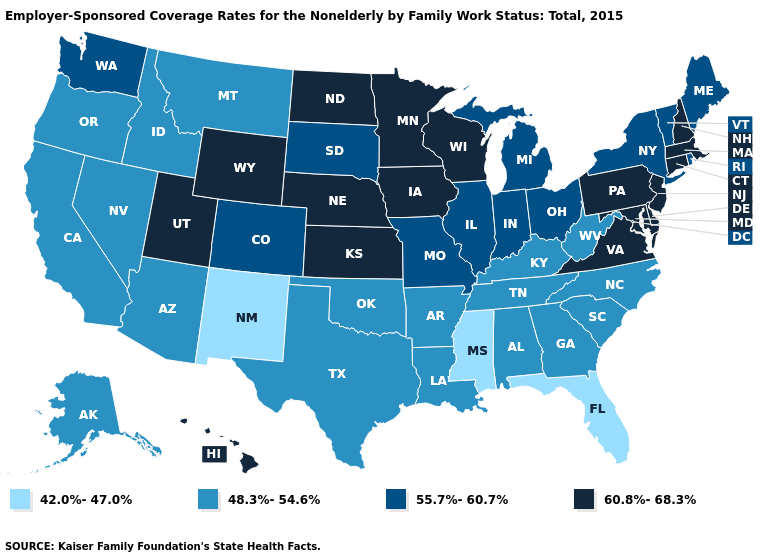How many symbols are there in the legend?
Answer briefly. 4. Is the legend a continuous bar?
Answer briefly. No. How many symbols are there in the legend?
Quick response, please. 4. What is the highest value in states that border Nevada?
Short answer required. 60.8%-68.3%. What is the value of Arkansas?
Concise answer only. 48.3%-54.6%. Name the states that have a value in the range 48.3%-54.6%?
Give a very brief answer. Alabama, Alaska, Arizona, Arkansas, California, Georgia, Idaho, Kentucky, Louisiana, Montana, Nevada, North Carolina, Oklahoma, Oregon, South Carolina, Tennessee, Texas, West Virginia. Name the states that have a value in the range 48.3%-54.6%?
Answer briefly. Alabama, Alaska, Arizona, Arkansas, California, Georgia, Idaho, Kentucky, Louisiana, Montana, Nevada, North Carolina, Oklahoma, Oregon, South Carolina, Tennessee, Texas, West Virginia. Does South Dakota have a lower value than Wisconsin?
Give a very brief answer. Yes. Name the states that have a value in the range 42.0%-47.0%?
Be succinct. Florida, Mississippi, New Mexico. Name the states that have a value in the range 42.0%-47.0%?
Short answer required. Florida, Mississippi, New Mexico. Name the states that have a value in the range 60.8%-68.3%?
Answer briefly. Connecticut, Delaware, Hawaii, Iowa, Kansas, Maryland, Massachusetts, Minnesota, Nebraska, New Hampshire, New Jersey, North Dakota, Pennsylvania, Utah, Virginia, Wisconsin, Wyoming. Name the states that have a value in the range 48.3%-54.6%?
Answer briefly. Alabama, Alaska, Arizona, Arkansas, California, Georgia, Idaho, Kentucky, Louisiana, Montana, Nevada, North Carolina, Oklahoma, Oregon, South Carolina, Tennessee, Texas, West Virginia. Which states have the highest value in the USA?
Give a very brief answer. Connecticut, Delaware, Hawaii, Iowa, Kansas, Maryland, Massachusetts, Minnesota, Nebraska, New Hampshire, New Jersey, North Dakota, Pennsylvania, Utah, Virginia, Wisconsin, Wyoming. Does Utah have the highest value in the West?
Answer briefly. Yes. Name the states that have a value in the range 42.0%-47.0%?
Quick response, please. Florida, Mississippi, New Mexico. 